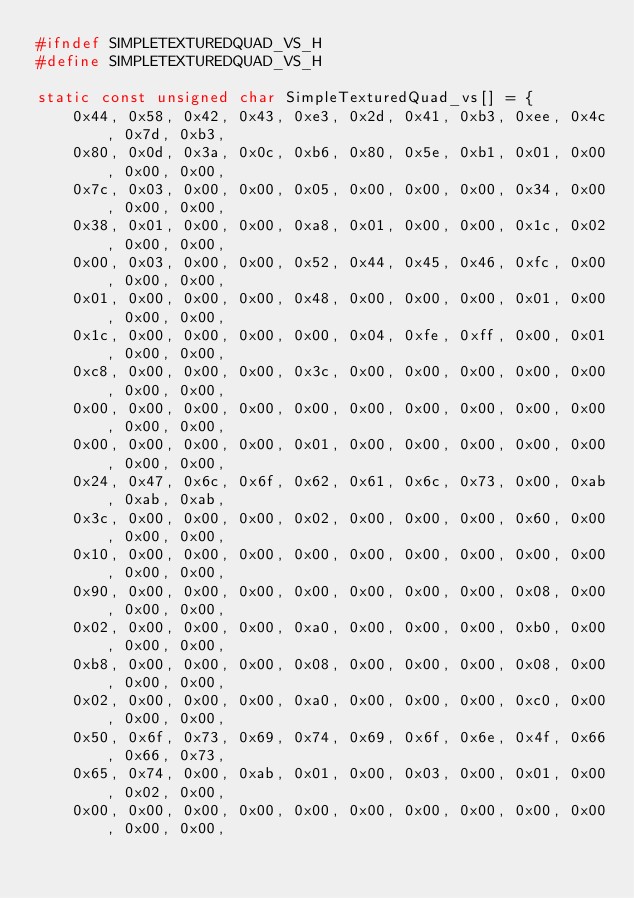Convert code to text. <code><loc_0><loc_0><loc_500><loc_500><_C_>#ifndef SIMPLETEXTUREDQUAD_VS_H
#define SIMPLETEXTUREDQUAD_VS_H

static const unsigned char SimpleTexturedQuad_vs[] = {
    0x44, 0x58, 0x42, 0x43, 0xe3, 0x2d, 0x41, 0xb3, 0xee, 0x4c, 0x7d, 0xb3, 
    0x80, 0x0d, 0x3a, 0x0c, 0xb6, 0x80, 0x5e, 0xb1, 0x01, 0x00, 0x00, 0x00, 
    0x7c, 0x03, 0x00, 0x00, 0x05, 0x00, 0x00, 0x00, 0x34, 0x00, 0x00, 0x00, 
    0x38, 0x01, 0x00, 0x00, 0xa8, 0x01, 0x00, 0x00, 0x1c, 0x02, 0x00, 0x00, 
    0x00, 0x03, 0x00, 0x00, 0x52, 0x44, 0x45, 0x46, 0xfc, 0x00, 0x00, 0x00, 
    0x01, 0x00, 0x00, 0x00, 0x48, 0x00, 0x00, 0x00, 0x01, 0x00, 0x00, 0x00, 
    0x1c, 0x00, 0x00, 0x00, 0x00, 0x04, 0xfe, 0xff, 0x00, 0x01, 0x00, 0x00, 
    0xc8, 0x00, 0x00, 0x00, 0x3c, 0x00, 0x00, 0x00, 0x00, 0x00, 0x00, 0x00, 
    0x00, 0x00, 0x00, 0x00, 0x00, 0x00, 0x00, 0x00, 0x00, 0x00, 0x00, 0x00, 
    0x00, 0x00, 0x00, 0x00, 0x01, 0x00, 0x00, 0x00, 0x00, 0x00, 0x00, 0x00, 
    0x24, 0x47, 0x6c, 0x6f, 0x62, 0x61, 0x6c, 0x73, 0x00, 0xab, 0xab, 0xab, 
    0x3c, 0x00, 0x00, 0x00, 0x02, 0x00, 0x00, 0x00, 0x60, 0x00, 0x00, 0x00, 
    0x10, 0x00, 0x00, 0x00, 0x00, 0x00, 0x00, 0x00, 0x00, 0x00, 0x00, 0x00, 
    0x90, 0x00, 0x00, 0x00, 0x00, 0x00, 0x00, 0x00, 0x08, 0x00, 0x00, 0x00, 
    0x02, 0x00, 0x00, 0x00, 0xa0, 0x00, 0x00, 0x00, 0xb0, 0x00, 0x00, 0x00, 
    0xb8, 0x00, 0x00, 0x00, 0x08, 0x00, 0x00, 0x00, 0x08, 0x00, 0x00, 0x00, 
    0x02, 0x00, 0x00, 0x00, 0xa0, 0x00, 0x00, 0x00, 0xc0, 0x00, 0x00, 0x00, 
    0x50, 0x6f, 0x73, 0x69, 0x74, 0x69, 0x6f, 0x6e, 0x4f, 0x66, 0x66, 0x73, 
    0x65, 0x74, 0x00, 0xab, 0x01, 0x00, 0x03, 0x00, 0x01, 0x00, 0x02, 0x00, 
    0x00, 0x00, 0x00, 0x00, 0x00, 0x00, 0x00, 0x00, 0x00, 0x00, 0x00, 0x00, </code> 